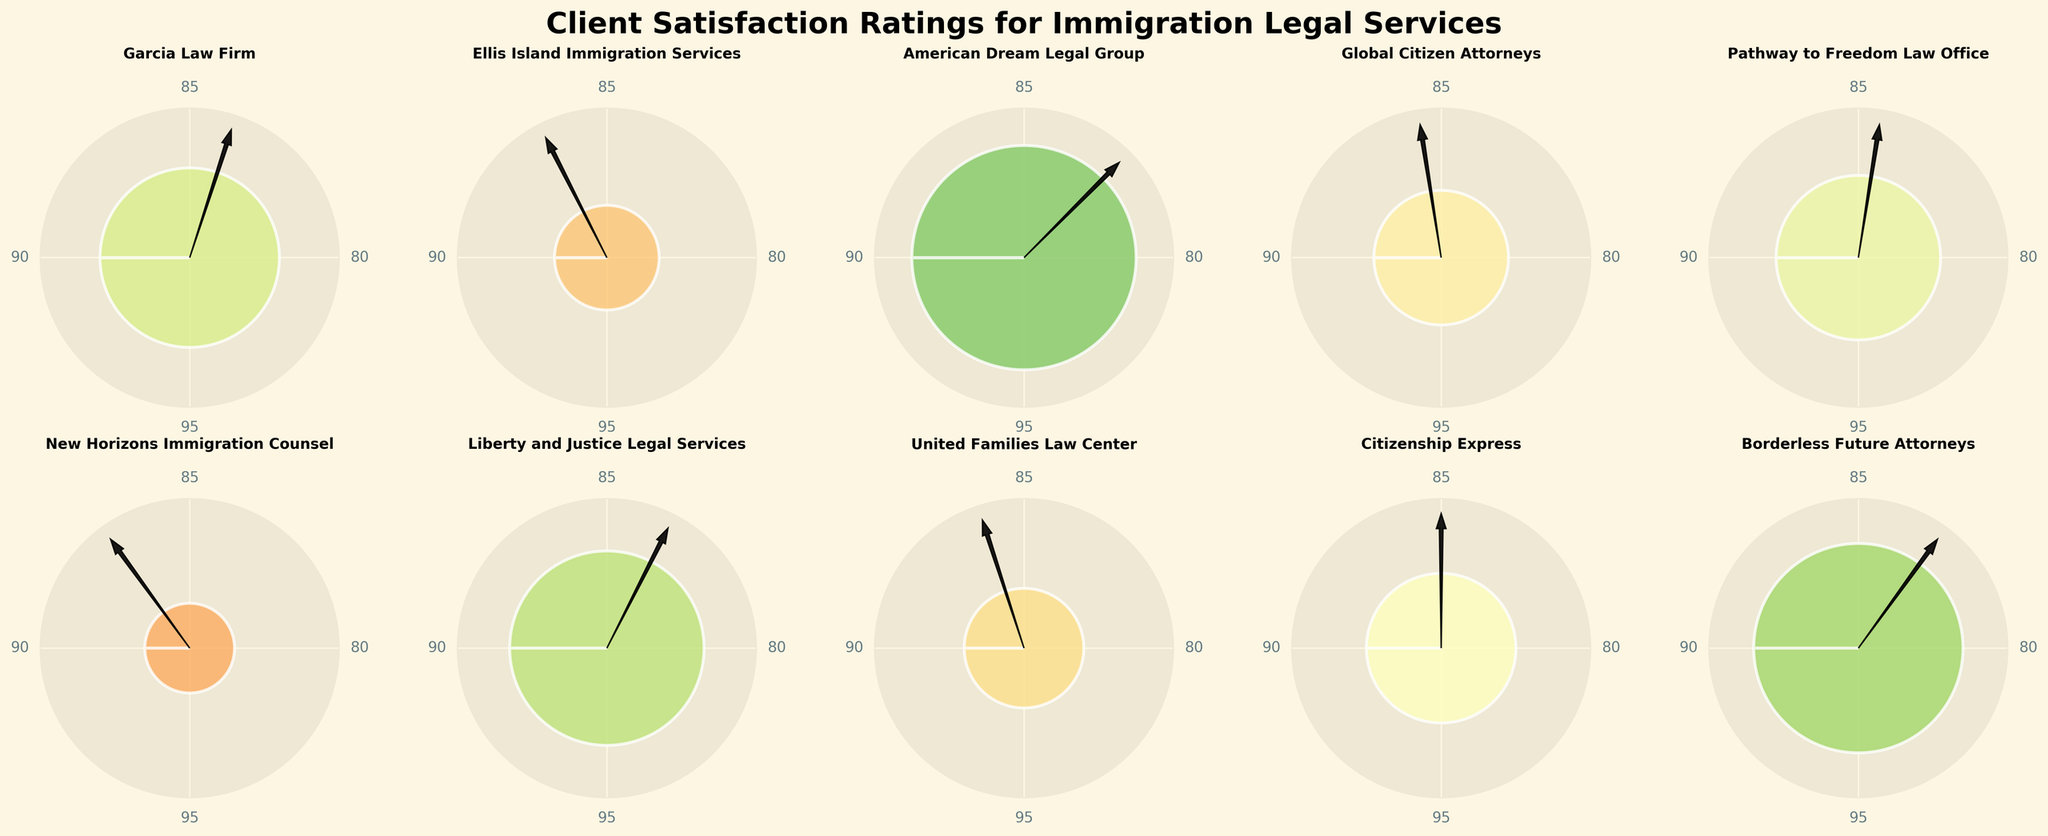What is the highest client satisfaction rating? The highest rating can be identified by looking at the gauge that reaches the farthest towards the "95" mark. The gauge for American Dream Legal Group reaches up to 95%, which is the highest.
Answer: 95% What is the title of the figure? The title is written at the top center of the figure. It reads: "Client Satisfaction Ratings for Immigration Legal Services".
Answer: Client Satisfaction Ratings for Immigration Legal Services Which two firms have satisfaction ratings above 90% but below 95%? By examining the gauges, we can check each firm's rating that is above 90% but does not reach 95%. The Garcia Law Firm with 92% and Liberty and Justice Legal Services with 93% meet these criteria.
Answer: Garcia Law Firm, Liberty and Justice Legal Services What is the mean satisfaction rating of all firms? Add all the satisfaction ratings and divide by the number of firms. (92+87+95+89+91+86+93+88+90+94) / 10 = 905 / 10 = 90.5
Answer: 90.5 Which firm has the lowest satisfaction rating? Look for the gauge that is the closest to "80". New Horizons Immigration Counsel has the rating closest to "80", specifically 86%.
Answer: New Horizons Immigration Counsel How many firms have satisfaction ratings equal to or above 90%? Count the number of firms with gauges pointing within the range marked "90" or higher: Garcia Law Firm, American Dream Legal Group, Pathway to Freedom Law Office, Liberty and Justice Legal Services, Citizenship Express, Borderless Future Attorneys. There are 6 firms.
Answer: 6 What is the rating for United Families Law Center? Find the gauge labeled "United Families Law Center". The gauge shows a rating of 88%.
Answer: 88% Which firm has a satisfaction rating that is exactly the median value? First, list all the ratings in ascending order: 86, 87, 88, 89, 90, 91, 92, 93, 94, 95. The median of these 10 values is the average of the 5th and 6th values: (90+91)/2 = 90.5. No firm's rating is exactly 90.5, but the two closest firms are Citizenship Express (90) and Pathway to Freedom Law Office (91).
Answer: Citizenship Express and Pathway to Freedom Law Office 